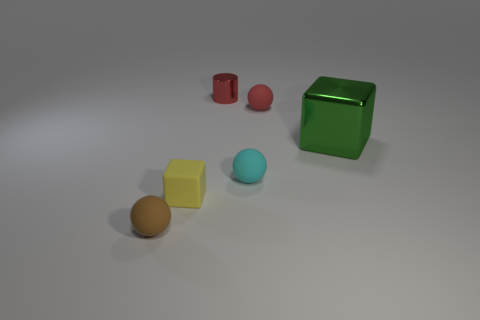Are there any other things that are the same size as the green block?
Make the answer very short. No. What is the size of the shiny object on the right side of the metallic object to the left of the sphere that is right of the cyan rubber object?
Give a very brief answer. Large. What material is the block right of the red object that is on the left side of the red sphere?
Offer a terse response. Metal. Are there any tiny brown objects that have the same shape as the small cyan object?
Ensure brevity in your answer.  Yes. The red rubber thing has what shape?
Provide a short and direct response. Sphere. There is a red thing that is on the left side of the tiny rubber thing that is behind the cube that is behind the yellow matte thing; what is it made of?
Make the answer very short. Metal. Are there more cyan balls that are in front of the small red ball than big metallic cylinders?
Keep it short and to the point. Yes. What is the material of the cylinder that is the same size as the yellow rubber object?
Offer a terse response. Metal. Is there a rubber cylinder that has the same size as the brown thing?
Ensure brevity in your answer.  No. There is a rubber object behind the large green object; what is its size?
Keep it short and to the point. Small. 